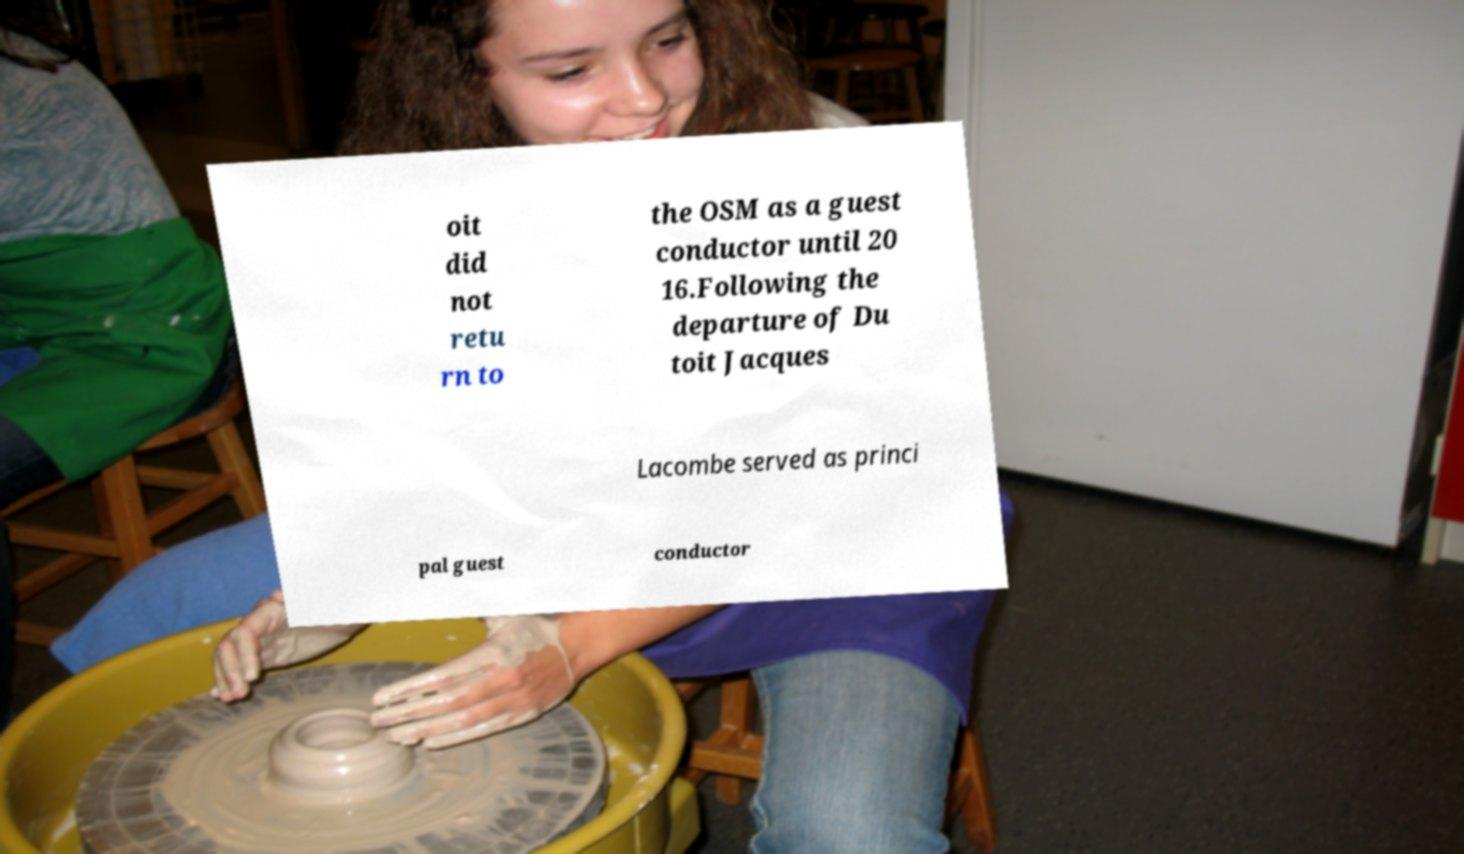Could you assist in decoding the text presented in this image and type it out clearly? oit did not retu rn to the OSM as a guest conductor until 20 16.Following the departure of Du toit Jacques Lacombe served as princi pal guest conductor 